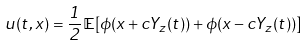<formula> <loc_0><loc_0><loc_500><loc_500>u ( t , x ) = \frac { 1 } { 2 } \mathbb { E } [ \phi ( x + c Y _ { z } ( t ) ) + \phi ( x - c Y _ { z } ( t ) ) ]</formula> 